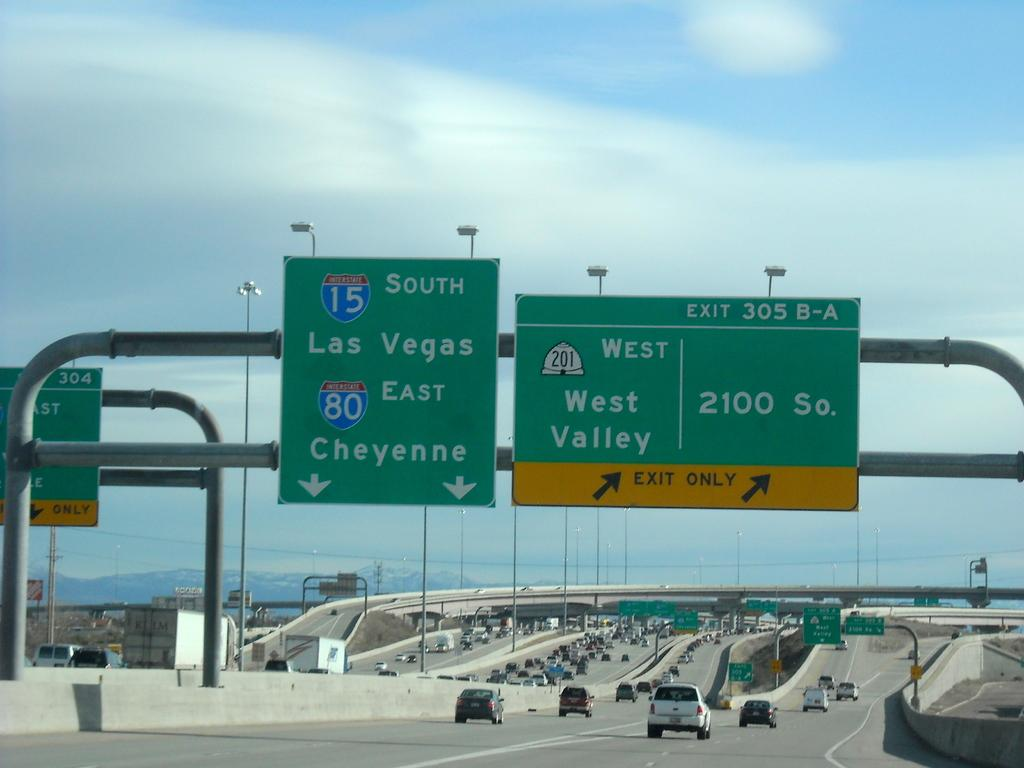<image>
Provide a brief description of the given image. An Interstate Sign displaying an option to hop on 15 South and go to Las Vegas. 